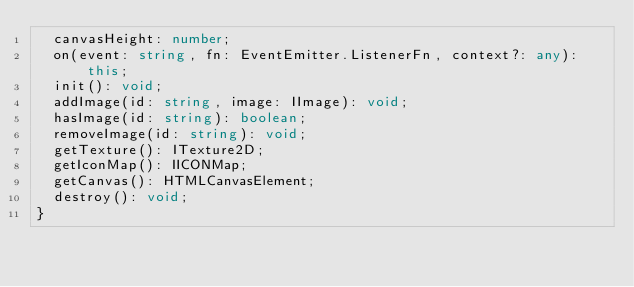Convert code to text. <code><loc_0><loc_0><loc_500><loc_500><_TypeScript_>  canvasHeight: number;
  on(event: string, fn: EventEmitter.ListenerFn, context?: any): this;
  init(): void;
  addImage(id: string, image: IImage): void;
  hasImage(id: string): boolean;
  removeImage(id: string): void;
  getTexture(): ITexture2D;
  getIconMap(): IICONMap;
  getCanvas(): HTMLCanvasElement;
  destroy(): void;
}
</code> 